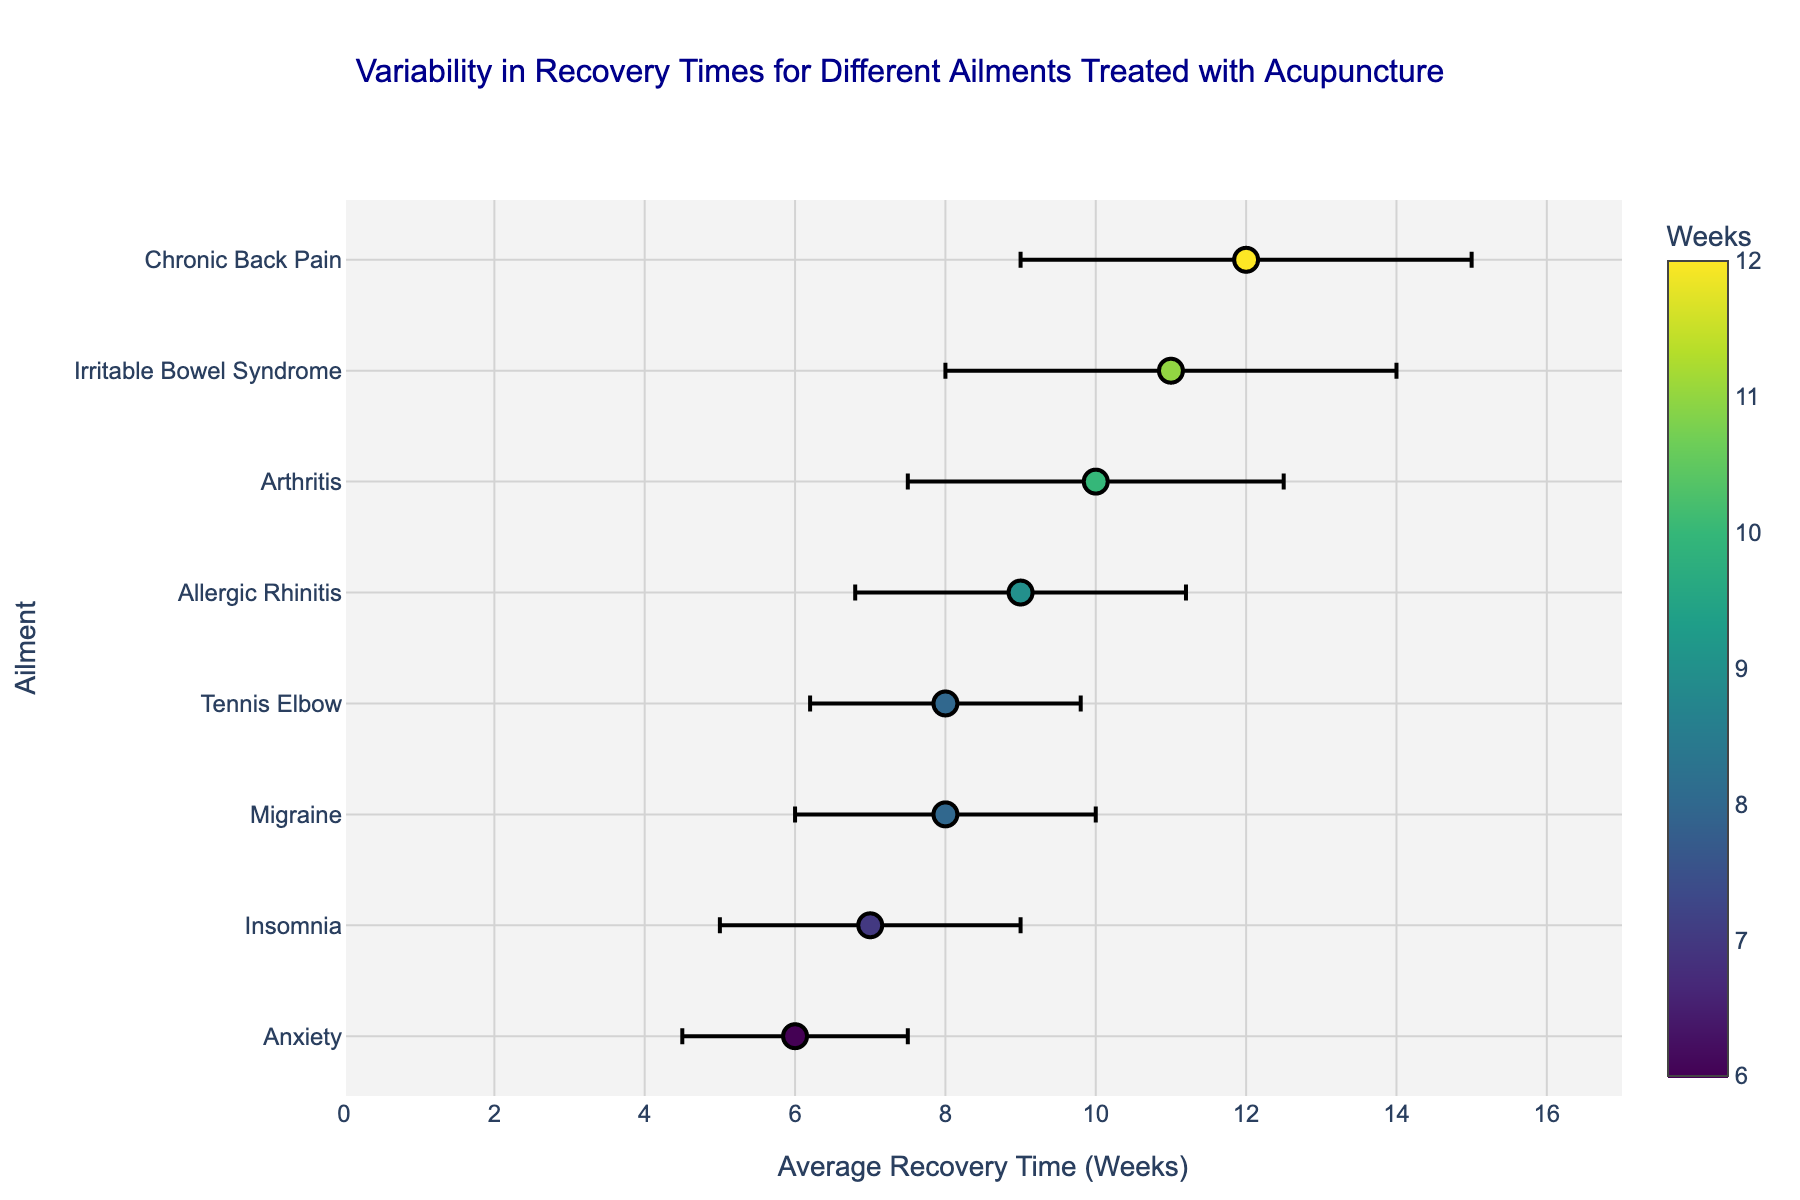What is the title of the figure? The title of the figure is displayed at the top and provides an overview of what the plot represents.
Answer: Variability in Recovery Times for Different Ailments Treated with Acupuncture How many ailments are shown in the figure? Count the unique ailment labels provided on the y-axis of the scatter plot.
Answer: 8 Which ailment has the highest average recovery time? Identify the ailment associated with the farthest data point to the right on the x-axis (Average Recovery Time).
Answer: Chronic Back Pain What is the standard deviation for the average recovery time of Anxiety? Locate the error bar for Anxiety on the plot and note its length, as it represents the standard deviation.
Answer: 1.5 weeks Which ailment has the lowest average recovery time, and what is that time? Find the ailment associated with the closest data point to the left on the x-axis and note its x-coordinate value.
Answer: Anxiety, 6 weeks Compare the average recovery times for Arthritis and Migraine. Which one is greater and by how much? Locate the data points for Arthritis and Migraine on the x-axis and note their values. Subtract to find the difference.
Answer: Arthritis is greater by 2 weeks What is the average of the average recovery times for Insomnia and Tennis Elbow? Find the values on the x-axis for Insomnia and Tennis Elbow, sum them and divide by two to get the average.
Answer: (7 + 8) / 2 = 7.5 weeks Which ailment has the highest variability in recovery times? Identify the ailment with the longest error bar, representing the highest standard deviation.
Answer: Chronic Back Pain, Irritable Bowel Syndrome Excluding Chronic Back Pain, which ailment has the highest average recovery time? Find the highest average recovery time value on the x-axis excluding the data point for Chronic Back Pain.
Answer: Irritable Bowel Syndrome, 11 weeks What is the range of the average recovery times shown in the figure? Subtract the smallest average recovery time on the x-axis from the largest average recovery time value.
Answer: 12 - 6 = 6 weeks 